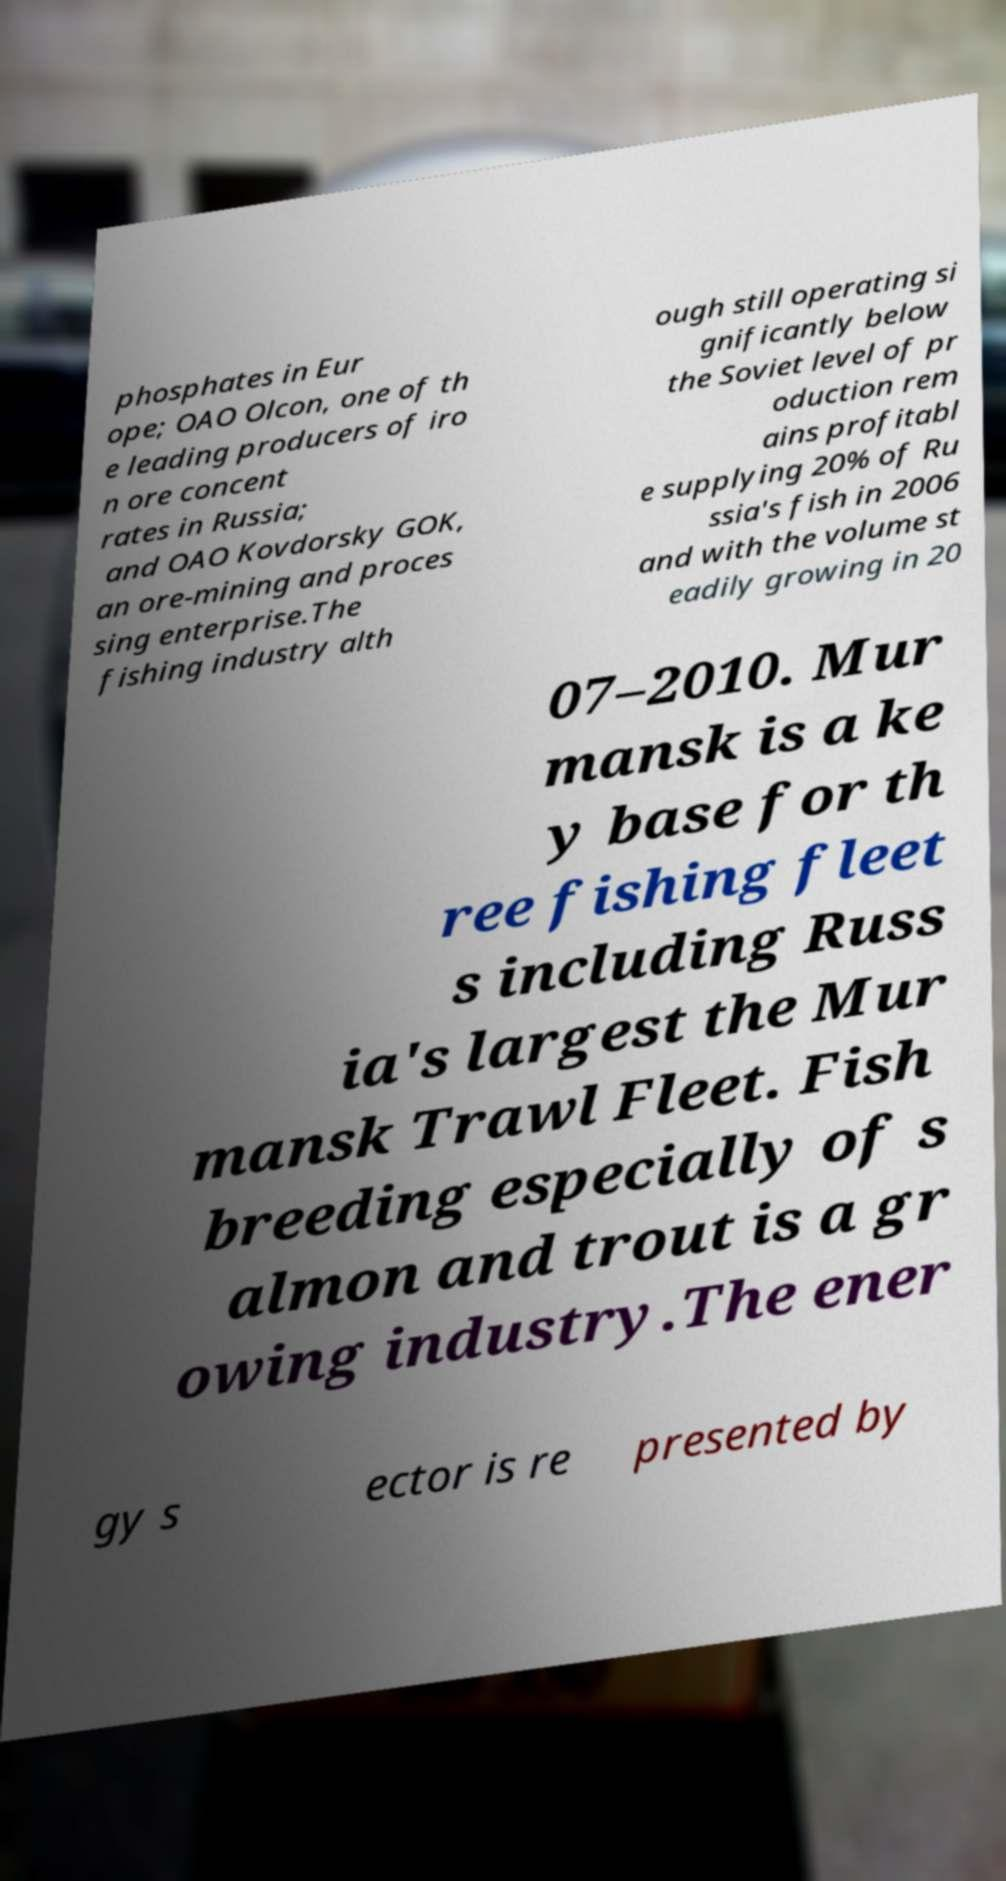Can you accurately transcribe the text from the provided image for me? phosphates in Eur ope; OAO Olcon, one of th e leading producers of iro n ore concent rates in Russia; and OAO Kovdorsky GOK, an ore-mining and proces sing enterprise.The fishing industry alth ough still operating si gnificantly below the Soviet level of pr oduction rem ains profitabl e supplying 20% of Ru ssia's fish in 2006 and with the volume st eadily growing in 20 07–2010. Mur mansk is a ke y base for th ree fishing fleet s including Russ ia's largest the Mur mansk Trawl Fleet. Fish breeding especially of s almon and trout is a gr owing industry.The ener gy s ector is re presented by 